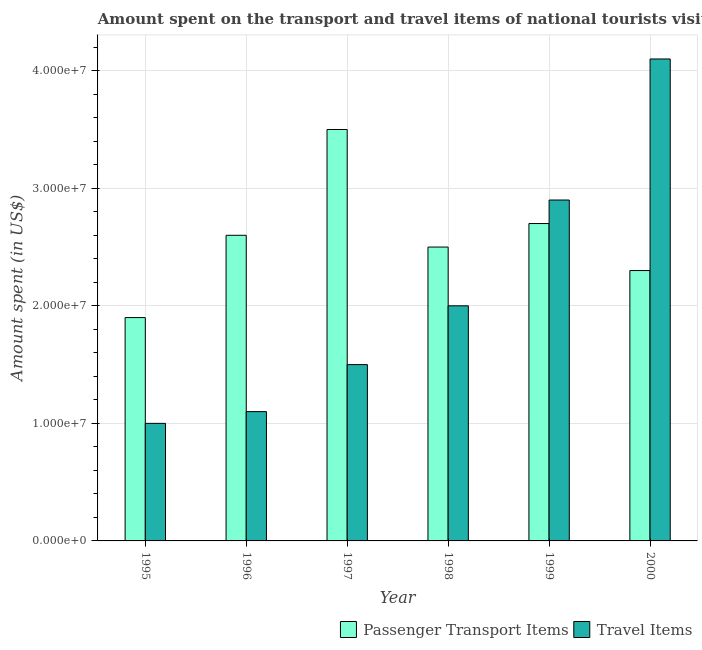How many different coloured bars are there?
Your answer should be very brief. 2. How many groups of bars are there?
Your answer should be compact. 6. Are the number of bars per tick equal to the number of legend labels?
Offer a terse response. Yes. Are the number of bars on each tick of the X-axis equal?
Your answer should be very brief. Yes. How many bars are there on the 4th tick from the right?
Give a very brief answer. 2. What is the label of the 1st group of bars from the left?
Make the answer very short. 1995. What is the amount spent in travel items in 1995?
Ensure brevity in your answer.  1.00e+07. Across all years, what is the maximum amount spent on passenger transport items?
Keep it short and to the point. 3.50e+07. Across all years, what is the minimum amount spent on passenger transport items?
Offer a very short reply. 1.90e+07. In which year was the amount spent on passenger transport items maximum?
Ensure brevity in your answer.  1997. What is the total amount spent on passenger transport items in the graph?
Provide a succinct answer. 1.55e+08. What is the difference between the amount spent in travel items in 1997 and that in 1999?
Offer a very short reply. -1.40e+07. What is the difference between the amount spent on passenger transport items in 1999 and the amount spent in travel items in 1998?
Provide a succinct answer. 2.00e+06. What is the average amount spent in travel items per year?
Your answer should be compact. 2.10e+07. What is the ratio of the amount spent on passenger transport items in 1996 to that in 1999?
Make the answer very short. 0.96. Is the amount spent on passenger transport items in 1997 less than that in 1999?
Make the answer very short. No. What is the difference between the highest and the lowest amount spent in travel items?
Make the answer very short. 3.10e+07. In how many years, is the amount spent on passenger transport items greater than the average amount spent on passenger transport items taken over all years?
Your answer should be compact. 3. What does the 2nd bar from the left in 1996 represents?
Make the answer very short. Travel Items. What does the 1st bar from the right in 1998 represents?
Your answer should be very brief. Travel Items. How many bars are there?
Your answer should be very brief. 12. Are all the bars in the graph horizontal?
Offer a very short reply. No. What is the difference between two consecutive major ticks on the Y-axis?
Ensure brevity in your answer.  1.00e+07. Does the graph contain grids?
Offer a terse response. Yes. What is the title of the graph?
Keep it short and to the point. Amount spent on the transport and travel items of national tourists visited in Cabo Verde. Does "Working capital" appear as one of the legend labels in the graph?
Ensure brevity in your answer.  No. What is the label or title of the X-axis?
Offer a very short reply. Year. What is the label or title of the Y-axis?
Make the answer very short. Amount spent (in US$). What is the Amount spent (in US$) in Passenger Transport Items in 1995?
Make the answer very short. 1.90e+07. What is the Amount spent (in US$) in Passenger Transport Items in 1996?
Give a very brief answer. 2.60e+07. What is the Amount spent (in US$) in Travel Items in 1996?
Your response must be concise. 1.10e+07. What is the Amount spent (in US$) of Passenger Transport Items in 1997?
Provide a succinct answer. 3.50e+07. What is the Amount spent (in US$) of Travel Items in 1997?
Keep it short and to the point. 1.50e+07. What is the Amount spent (in US$) of Passenger Transport Items in 1998?
Offer a very short reply. 2.50e+07. What is the Amount spent (in US$) of Passenger Transport Items in 1999?
Your answer should be very brief. 2.70e+07. What is the Amount spent (in US$) in Travel Items in 1999?
Keep it short and to the point. 2.90e+07. What is the Amount spent (in US$) of Passenger Transport Items in 2000?
Offer a terse response. 2.30e+07. What is the Amount spent (in US$) of Travel Items in 2000?
Your answer should be very brief. 4.10e+07. Across all years, what is the maximum Amount spent (in US$) of Passenger Transport Items?
Your answer should be very brief. 3.50e+07. Across all years, what is the maximum Amount spent (in US$) of Travel Items?
Give a very brief answer. 4.10e+07. Across all years, what is the minimum Amount spent (in US$) of Passenger Transport Items?
Give a very brief answer. 1.90e+07. What is the total Amount spent (in US$) in Passenger Transport Items in the graph?
Your answer should be compact. 1.55e+08. What is the total Amount spent (in US$) in Travel Items in the graph?
Offer a very short reply. 1.26e+08. What is the difference between the Amount spent (in US$) in Passenger Transport Items in 1995 and that in 1996?
Your response must be concise. -7.00e+06. What is the difference between the Amount spent (in US$) of Travel Items in 1995 and that in 1996?
Your answer should be very brief. -1.00e+06. What is the difference between the Amount spent (in US$) of Passenger Transport Items in 1995 and that in 1997?
Your answer should be compact. -1.60e+07. What is the difference between the Amount spent (in US$) in Travel Items in 1995 and that in 1997?
Provide a short and direct response. -5.00e+06. What is the difference between the Amount spent (in US$) in Passenger Transport Items in 1995 and that in 1998?
Your answer should be compact. -6.00e+06. What is the difference between the Amount spent (in US$) of Travel Items in 1995 and that in 1998?
Offer a terse response. -1.00e+07. What is the difference between the Amount spent (in US$) in Passenger Transport Items in 1995 and that in 1999?
Your answer should be very brief. -8.00e+06. What is the difference between the Amount spent (in US$) in Travel Items in 1995 and that in 1999?
Ensure brevity in your answer.  -1.90e+07. What is the difference between the Amount spent (in US$) in Passenger Transport Items in 1995 and that in 2000?
Ensure brevity in your answer.  -4.00e+06. What is the difference between the Amount spent (in US$) in Travel Items in 1995 and that in 2000?
Your answer should be very brief. -3.10e+07. What is the difference between the Amount spent (in US$) in Passenger Transport Items in 1996 and that in 1997?
Ensure brevity in your answer.  -9.00e+06. What is the difference between the Amount spent (in US$) of Travel Items in 1996 and that in 1997?
Offer a very short reply. -4.00e+06. What is the difference between the Amount spent (in US$) of Passenger Transport Items in 1996 and that in 1998?
Provide a short and direct response. 1.00e+06. What is the difference between the Amount spent (in US$) in Travel Items in 1996 and that in 1998?
Your response must be concise. -9.00e+06. What is the difference between the Amount spent (in US$) of Passenger Transport Items in 1996 and that in 1999?
Your answer should be very brief. -1.00e+06. What is the difference between the Amount spent (in US$) in Travel Items in 1996 and that in 1999?
Your answer should be very brief. -1.80e+07. What is the difference between the Amount spent (in US$) in Travel Items in 1996 and that in 2000?
Offer a terse response. -3.00e+07. What is the difference between the Amount spent (in US$) of Passenger Transport Items in 1997 and that in 1998?
Give a very brief answer. 1.00e+07. What is the difference between the Amount spent (in US$) in Travel Items in 1997 and that in 1998?
Offer a terse response. -5.00e+06. What is the difference between the Amount spent (in US$) in Passenger Transport Items in 1997 and that in 1999?
Your response must be concise. 8.00e+06. What is the difference between the Amount spent (in US$) of Travel Items in 1997 and that in 1999?
Provide a succinct answer. -1.40e+07. What is the difference between the Amount spent (in US$) of Passenger Transport Items in 1997 and that in 2000?
Keep it short and to the point. 1.20e+07. What is the difference between the Amount spent (in US$) of Travel Items in 1997 and that in 2000?
Give a very brief answer. -2.60e+07. What is the difference between the Amount spent (in US$) in Travel Items in 1998 and that in 1999?
Ensure brevity in your answer.  -9.00e+06. What is the difference between the Amount spent (in US$) of Travel Items in 1998 and that in 2000?
Provide a short and direct response. -2.10e+07. What is the difference between the Amount spent (in US$) of Passenger Transport Items in 1999 and that in 2000?
Your answer should be compact. 4.00e+06. What is the difference between the Amount spent (in US$) in Travel Items in 1999 and that in 2000?
Provide a succinct answer. -1.20e+07. What is the difference between the Amount spent (in US$) of Passenger Transport Items in 1995 and the Amount spent (in US$) of Travel Items in 1997?
Ensure brevity in your answer.  4.00e+06. What is the difference between the Amount spent (in US$) in Passenger Transport Items in 1995 and the Amount spent (in US$) in Travel Items in 1999?
Make the answer very short. -1.00e+07. What is the difference between the Amount spent (in US$) in Passenger Transport Items in 1995 and the Amount spent (in US$) in Travel Items in 2000?
Provide a short and direct response. -2.20e+07. What is the difference between the Amount spent (in US$) in Passenger Transport Items in 1996 and the Amount spent (in US$) in Travel Items in 1997?
Your response must be concise. 1.10e+07. What is the difference between the Amount spent (in US$) of Passenger Transport Items in 1996 and the Amount spent (in US$) of Travel Items in 1998?
Make the answer very short. 6.00e+06. What is the difference between the Amount spent (in US$) in Passenger Transport Items in 1996 and the Amount spent (in US$) in Travel Items in 2000?
Your answer should be compact. -1.50e+07. What is the difference between the Amount spent (in US$) of Passenger Transport Items in 1997 and the Amount spent (in US$) of Travel Items in 1998?
Ensure brevity in your answer.  1.50e+07. What is the difference between the Amount spent (in US$) of Passenger Transport Items in 1997 and the Amount spent (in US$) of Travel Items in 1999?
Provide a succinct answer. 6.00e+06. What is the difference between the Amount spent (in US$) of Passenger Transport Items in 1997 and the Amount spent (in US$) of Travel Items in 2000?
Offer a very short reply. -6.00e+06. What is the difference between the Amount spent (in US$) in Passenger Transport Items in 1998 and the Amount spent (in US$) in Travel Items in 1999?
Make the answer very short. -4.00e+06. What is the difference between the Amount spent (in US$) of Passenger Transport Items in 1998 and the Amount spent (in US$) of Travel Items in 2000?
Ensure brevity in your answer.  -1.60e+07. What is the difference between the Amount spent (in US$) of Passenger Transport Items in 1999 and the Amount spent (in US$) of Travel Items in 2000?
Provide a short and direct response. -1.40e+07. What is the average Amount spent (in US$) of Passenger Transport Items per year?
Make the answer very short. 2.58e+07. What is the average Amount spent (in US$) in Travel Items per year?
Your response must be concise. 2.10e+07. In the year 1995, what is the difference between the Amount spent (in US$) in Passenger Transport Items and Amount spent (in US$) in Travel Items?
Make the answer very short. 9.00e+06. In the year 1996, what is the difference between the Amount spent (in US$) in Passenger Transport Items and Amount spent (in US$) in Travel Items?
Offer a very short reply. 1.50e+07. In the year 1997, what is the difference between the Amount spent (in US$) of Passenger Transport Items and Amount spent (in US$) of Travel Items?
Keep it short and to the point. 2.00e+07. In the year 1998, what is the difference between the Amount spent (in US$) in Passenger Transport Items and Amount spent (in US$) in Travel Items?
Offer a terse response. 5.00e+06. In the year 1999, what is the difference between the Amount spent (in US$) in Passenger Transport Items and Amount spent (in US$) in Travel Items?
Your answer should be compact. -2.00e+06. In the year 2000, what is the difference between the Amount spent (in US$) in Passenger Transport Items and Amount spent (in US$) in Travel Items?
Provide a succinct answer. -1.80e+07. What is the ratio of the Amount spent (in US$) of Passenger Transport Items in 1995 to that in 1996?
Your answer should be very brief. 0.73. What is the ratio of the Amount spent (in US$) in Passenger Transport Items in 1995 to that in 1997?
Offer a terse response. 0.54. What is the ratio of the Amount spent (in US$) of Passenger Transport Items in 1995 to that in 1998?
Give a very brief answer. 0.76. What is the ratio of the Amount spent (in US$) in Travel Items in 1995 to that in 1998?
Your answer should be compact. 0.5. What is the ratio of the Amount spent (in US$) in Passenger Transport Items in 1995 to that in 1999?
Offer a terse response. 0.7. What is the ratio of the Amount spent (in US$) of Travel Items in 1995 to that in 1999?
Provide a short and direct response. 0.34. What is the ratio of the Amount spent (in US$) of Passenger Transport Items in 1995 to that in 2000?
Make the answer very short. 0.83. What is the ratio of the Amount spent (in US$) of Travel Items in 1995 to that in 2000?
Your answer should be very brief. 0.24. What is the ratio of the Amount spent (in US$) of Passenger Transport Items in 1996 to that in 1997?
Offer a terse response. 0.74. What is the ratio of the Amount spent (in US$) of Travel Items in 1996 to that in 1997?
Ensure brevity in your answer.  0.73. What is the ratio of the Amount spent (in US$) in Passenger Transport Items in 1996 to that in 1998?
Offer a terse response. 1.04. What is the ratio of the Amount spent (in US$) in Travel Items in 1996 to that in 1998?
Provide a succinct answer. 0.55. What is the ratio of the Amount spent (in US$) of Passenger Transport Items in 1996 to that in 1999?
Offer a terse response. 0.96. What is the ratio of the Amount spent (in US$) of Travel Items in 1996 to that in 1999?
Make the answer very short. 0.38. What is the ratio of the Amount spent (in US$) in Passenger Transport Items in 1996 to that in 2000?
Keep it short and to the point. 1.13. What is the ratio of the Amount spent (in US$) in Travel Items in 1996 to that in 2000?
Your response must be concise. 0.27. What is the ratio of the Amount spent (in US$) in Passenger Transport Items in 1997 to that in 1999?
Provide a short and direct response. 1.3. What is the ratio of the Amount spent (in US$) in Travel Items in 1997 to that in 1999?
Provide a short and direct response. 0.52. What is the ratio of the Amount spent (in US$) in Passenger Transport Items in 1997 to that in 2000?
Offer a very short reply. 1.52. What is the ratio of the Amount spent (in US$) of Travel Items in 1997 to that in 2000?
Offer a terse response. 0.37. What is the ratio of the Amount spent (in US$) in Passenger Transport Items in 1998 to that in 1999?
Offer a very short reply. 0.93. What is the ratio of the Amount spent (in US$) in Travel Items in 1998 to that in 1999?
Provide a short and direct response. 0.69. What is the ratio of the Amount spent (in US$) of Passenger Transport Items in 1998 to that in 2000?
Offer a very short reply. 1.09. What is the ratio of the Amount spent (in US$) of Travel Items in 1998 to that in 2000?
Ensure brevity in your answer.  0.49. What is the ratio of the Amount spent (in US$) in Passenger Transport Items in 1999 to that in 2000?
Provide a succinct answer. 1.17. What is the ratio of the Amount spent (in US$) in Travel Items in 1999 to that in 2000?
Offer a terse response. 0.71. What is the difference between the highest and the second highest Amount spent (in US$) in Passenger Transport Items?
Your answer should be compact. 8.00e+06. What is the difference between the highest and the lowest Amount spent (in US$) in Passenger Transport Items?
Make the answer very short. 1.60e+07. What is the difference between the highest and the lowest Amount spent (in US$) of Travel Items?
Provide a succinct answer. 3.10e+07. 